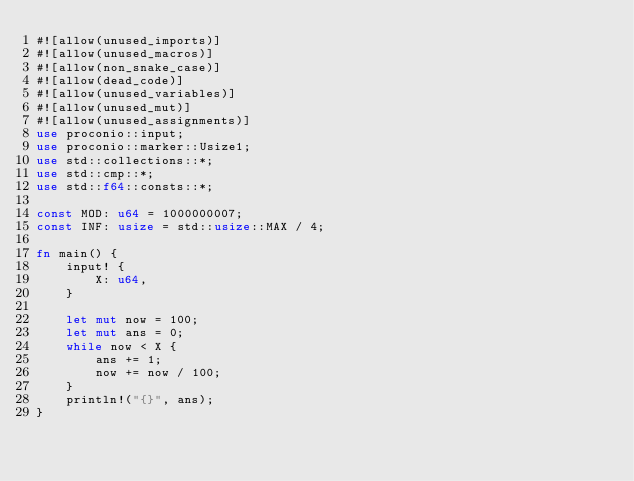Convert code to text. <code><loc_0><loc_0><loc_500><loc_500><_Rust_>#![allow(unused_imports)]
#![allow(unused_macros)]
#![allow(non_snake_case)]
#![allow(dead_code)]
#![allow(unused_variables)]
#![allow(unused_mut)]
#![allow(unused_assignments)]
use proconio::input;
use proconio::marker::Usize1;
use std::collections::*;
use std::cmp::*;
use std::f64::consts::*;

const MOD: u64 = 1000000007;
const INF: usize = std::usize::MAX / 4;

fn main() {
    input! {
        X: u64,
    }

    let mut now = 100;
    let mut ans = 0;
    while now < X {
        ans += 1;
        now += now / 100;
    }
    println!("{}", ans);
}
</code> 